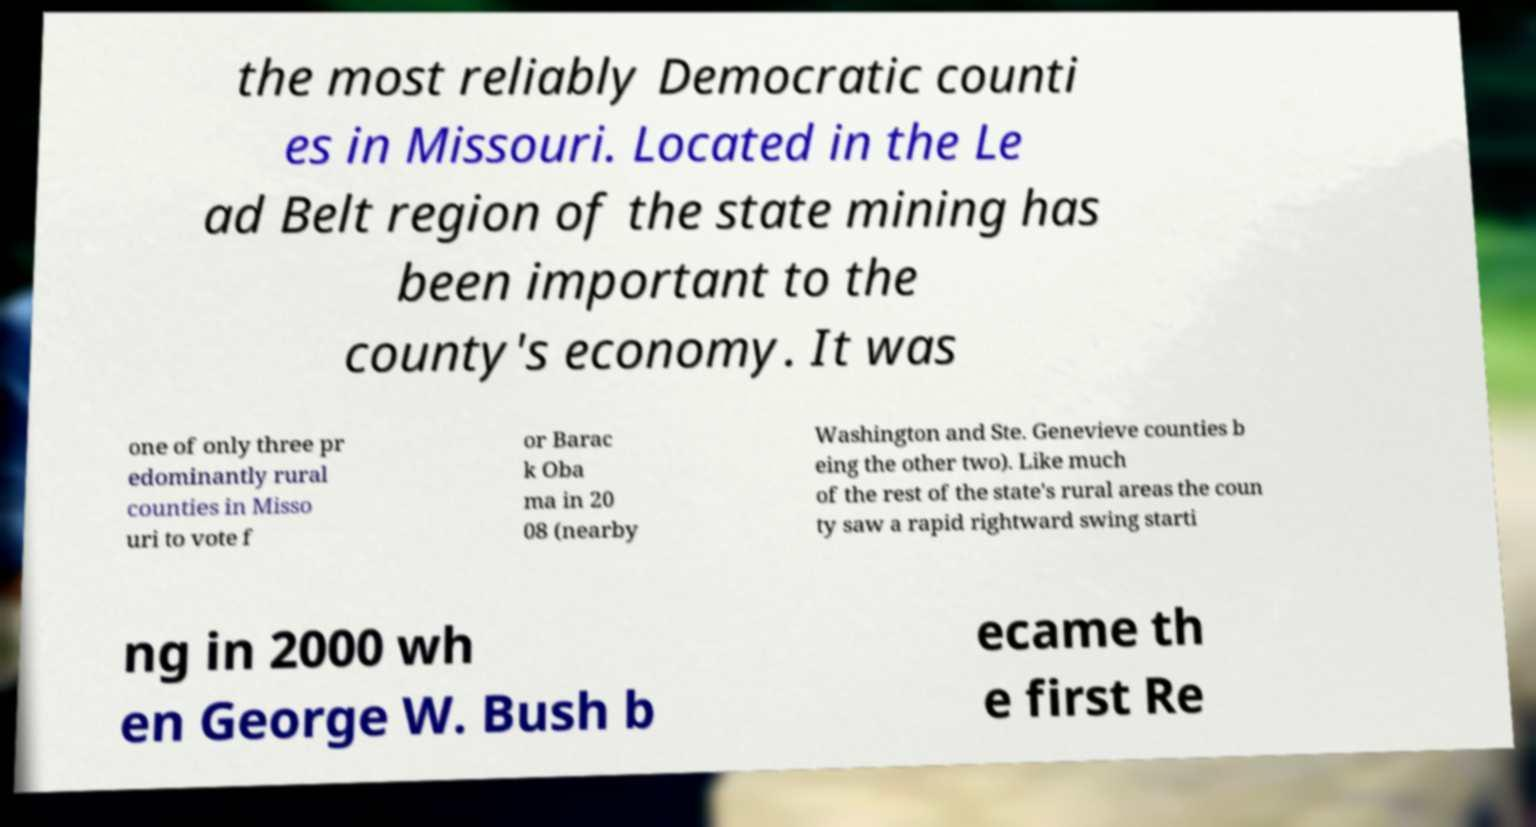Can you read and provide the text displayed in the image?This photo seems to have some interesting text. Can you extract and type it out for me? the most reliably Democratic counti es in Missouri. Located in the Le ad Belt region of the state mining has been important to the county's economy. It was one of only three pr edominantly rural counties in Misso uri to vote f or Barac k Oba ma in 20 08 (nearby Washington and Ste. Genevieve counties b eing the other two). Like much of the rest of the state's rural areas the coun ty saw a rapid rightward swing starti ng in 2000 wh en George W. Bush b ecame th e first Re 